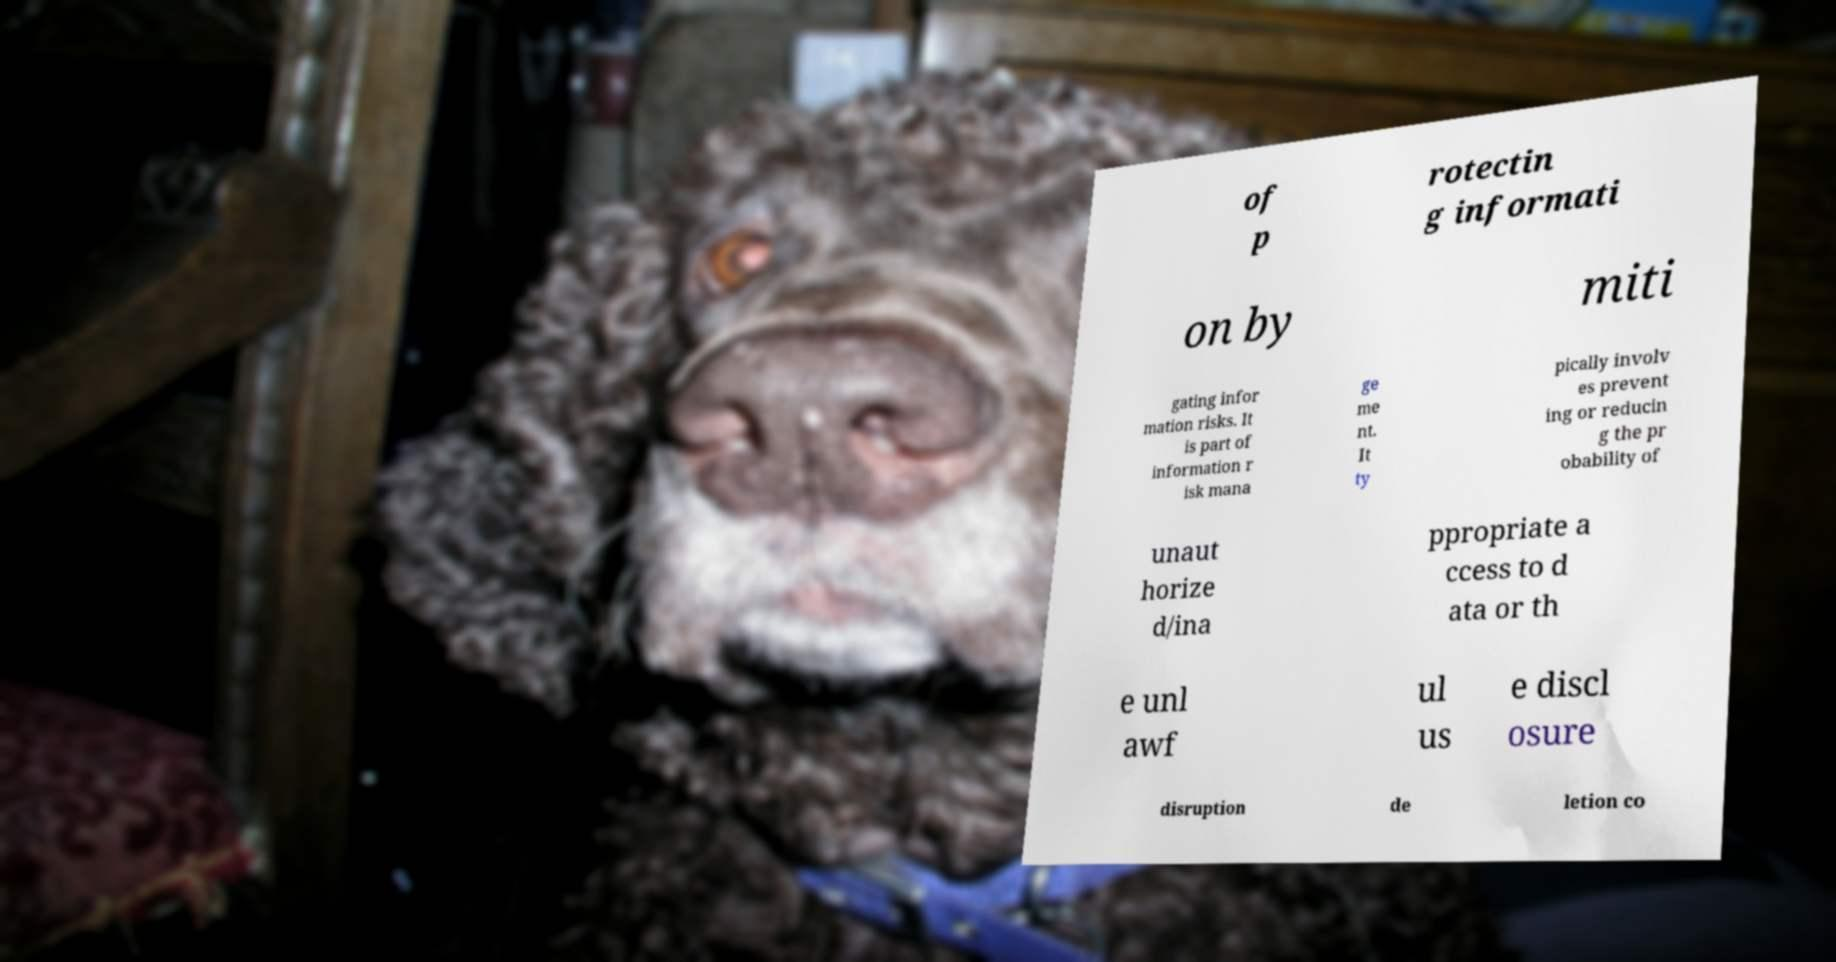Could you extract and type out the text from this image? of p rotectin g informati on by miti gating infor mation risks. It is part of information r isk mana ge me nt. It ty pically involv es prevent ing or reducin g the pr obability of unaut horize d/ina ppropriate a ccess to d ata or th e unl awf ul us e discl osure disruption de letion co 